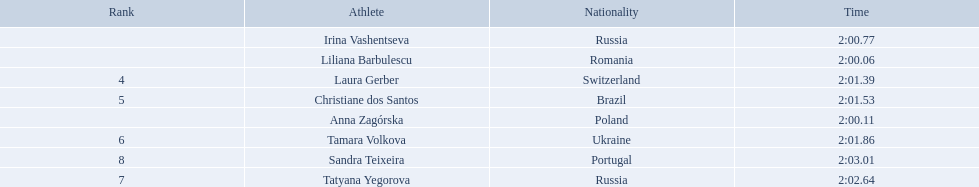Who were the athlete were in the athletics at the 2003 summer universiade - women's 800 metres? , Liliana Barbulescu, Anna Zagórska, Irina Vashentseva, Laura Gerber, Christiane dos Santos, Tamara Volkova, Tatyana Yegorova, Sandra Teixeira. What was anna zagorska finishing time? 2:00.11. What are the names of the competitors? Liliana Barbulescu, Anna Zagórska, Irina Vashentseva, Laura Gerber, Christiane dos Santos, Tamara Volkova, Tatyana Yegorova, Sandra Teixeira. Which finalist finished the fastest? Liliana Barbulescu. 